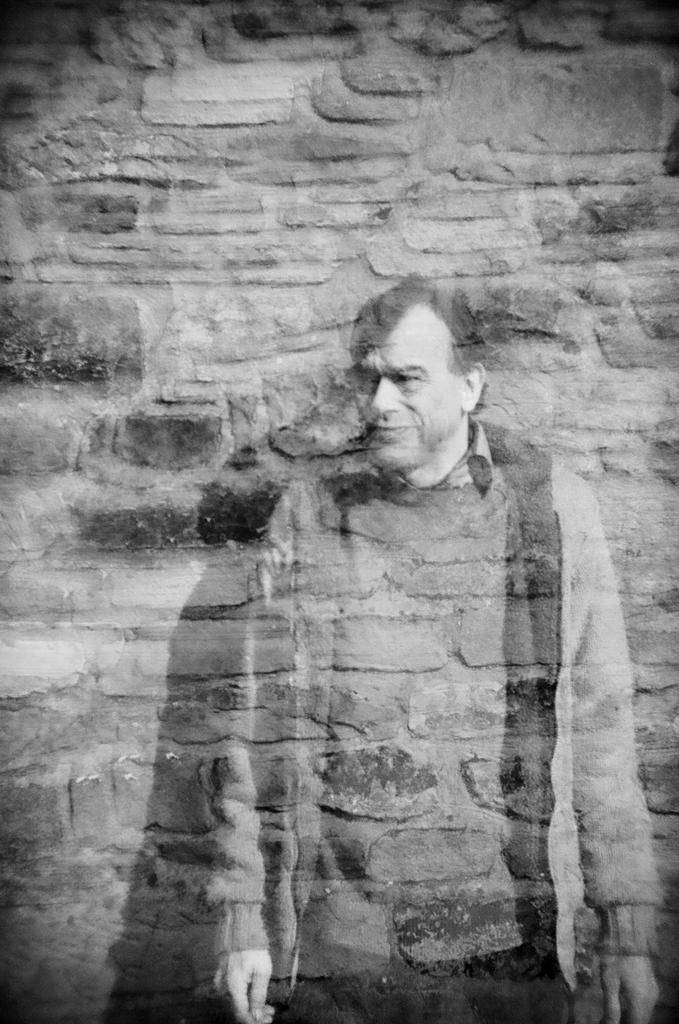How has the image been altered? The image is edited and black and white. What can be seen in the image besides the editing? There is a person standing in the image. What is the background of the image? There is a wall at the top of the image. How many oranges are on the person's pocket in the image? There are no oranges or pockets visible in the image. What type of snail can be seen crawling on the wall in the image? There are no snails present in the image; it only features a person and a wall. 